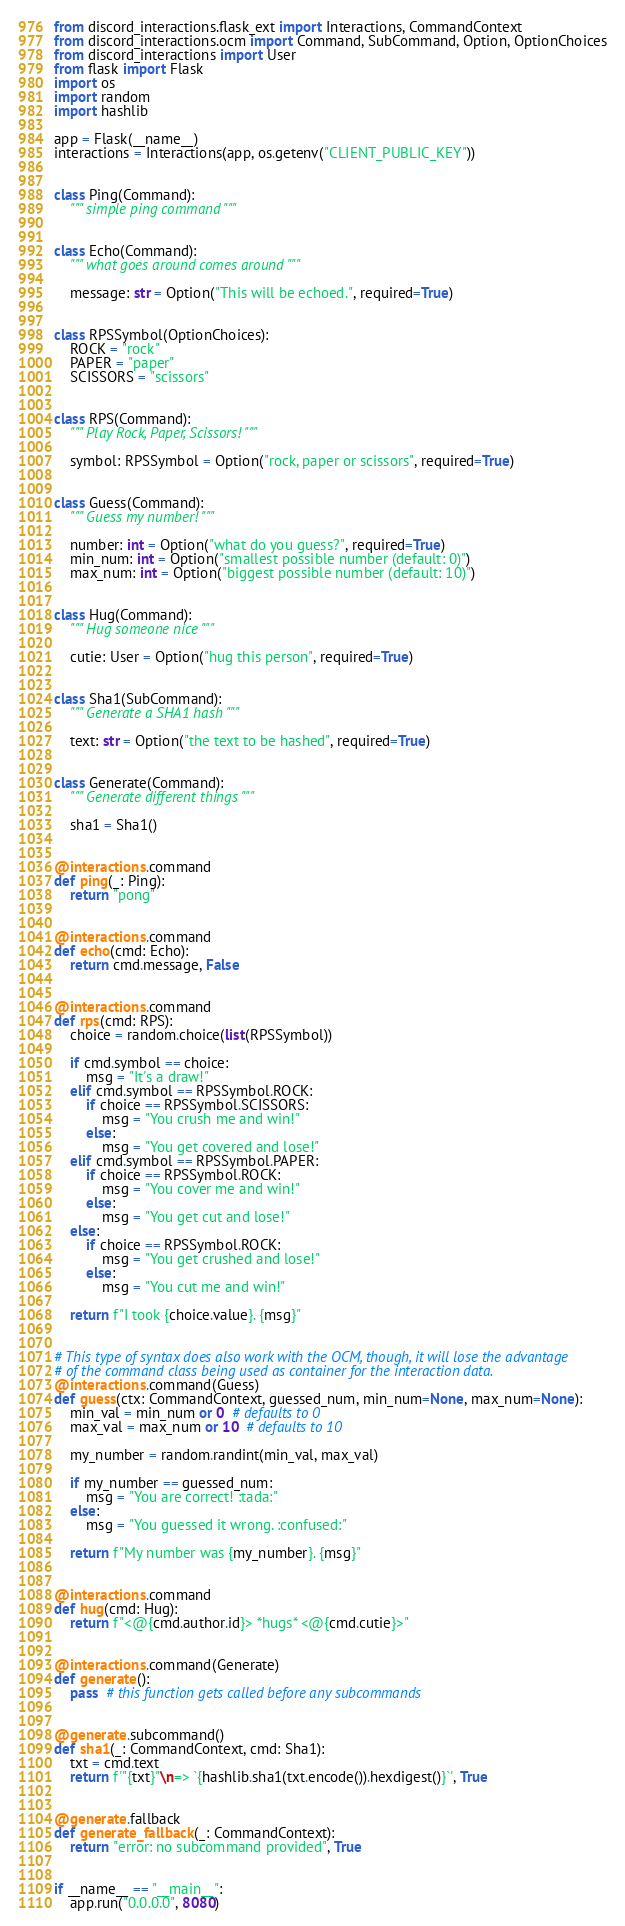<code> <loc_0><loc_0><loc_500><loc_500><_Python_>from discord_interactions.flask_ext import Interactions, CommandContext
from discord_interactions.ocm import Command, SubCommand, Option, OptionChoices
from discord_interactions import User
from flask import Flask
import os
import random
import hashlib

app = Flask(__name__)
interactions = Interactions(app, os.getenv("CLIENT_PUBLIC_KEY"))


class Ping(Command):
    """ simple ping command """


class Echo(Command):
    """ what goes around comes around """

    message: str = Option("This will be echoed.", required=True)


class RPSSymbol(OptionChoices):
    ROCK = "rock"
    PAPER = "paper"
    SCISSORS = "scissors"


class RPS(Command):
    """ Play Rock, Paper, Scissors! """

    symbol: RPSSymbol = Option("rock, paper or scissors", required=True)


class Guess(Command):
    """ Guess my number! """

    number: int = Option("what do you guess?", required=True)
    min_num: int = Option("smallest possible number (default: 0)")
    max_num: int = Option("biggest possible number (default: 10)")


class Hug(Command):
    """ Hug someone nice """

    cutie: User = Option("hug this person", required=True)


class Sha1(SubCommand):
    """ Generate a SHA1 hash """

    text: str = Option("the text to be hashed", required=True)


class Generate(Command):
    """ Generate different things """

    sha1 = Sha1()


@interactions.command
def ping(_: Ping):
    return "pong"


@interactions.command
def echo(cmd: Echo):
    return cmd.message, False


@interactions.command
def rps(cmd: RPS):
    choice = random.choice(list(RPSSymbol))

    if cmd.symbol == choice:
        msg = "It's a draw!"
    elif cmd.symbol == RPSSymbol.ROCK:
        if choice == RPSSymbol.SCISSORS:
            msg = "You crush me and win!"
        else:
            msg = "You get covered and lose!"
    elif cmd.symbol == RPSSymbol.PAPER:
        if choice == RPSSymbol.ROCK:
            msg = "You cover me and win!"
        else:
            msg = "You get cut and lose!"
    else:
        if choice == RPSSymbol.ROCK:
            msg = "You get crushed and lose!"
        else:
            msg = "You cut me and win!"

    return f"I took {choice.value}. {msg}"


# This type of syntax does also work with the OCM, though, it will lose the advantage
# of the command class being used as container for the interaction data.
@interactions.command(Guess)
def guess(ctx: CommandContext, guessed_num, min_num=None, max_num=None):
    min_val = min_num or 0  # defaults to 0
    max_val = max_num or 10  # defaults to 10

    my_number = random.randint(min_val, max_val)

    if my_number == guessed_num:
        msg = "You are correct! :tada:"
    else:
        msg = "You guessed it wrong. :confused:"

    return f"My number was {my_number}. {msg}"


@interactions.command
def hug(cmd: Hug):
    return f"<@{cmd.author.id}> *hugs* <@{cmd.cutie}>"


@interactions.command(Generate)
def generate():
    pass  # this function gets called before any subcommands


@generate.subcommand()
def sha1(_: CommandContext, cmd: Sha1):
    txt = cmd.text
    return f'"{txt}"\n=> `{hashlib.sha1(txt.encode()).hexdigest()}`', True


@generate.fallback
def generate_fallback(_: CommandContext):
    return "error: no subcommand provided", True


if __name__ == "__main__":
    app.run("0.0.0.0", 8080)
</code> 